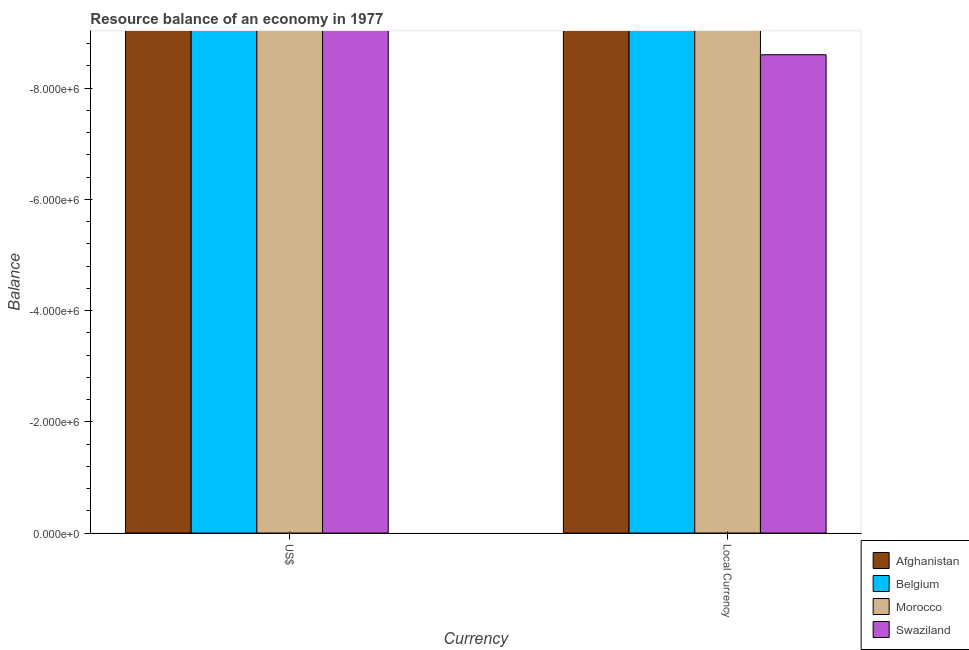How many different coloured bars are there?
Keep it short and to the point. 0. What is the label of the 1st group of bars from the left?
Your answer should be very brief. US$. What is the resource balance in constant us$ in Belgium?
Ensure brevity in your answer.  0. In how many countries, is the resource balance in us$ greater than the average resource balance in us$ taken over all countries?
Give a very brief answer. 0. How many bars are there?
Your answer should be compact. 0. Are all the bars in the graph horizontal?
Keep it short and to the point. No. What is the difference between two consecutive major ticks on the Y-axis?
Offer a terse response. 2.00e+06. Does the graph contain grids?
Keep it short and to the point. No. Where does the legend appear in the graph?
Provide a succinct answer. Bottom right. How are the legend labels stacked?
Ensure brevity in your answer.  Vertical. What is the title of the graph?
Your response must be concise. Resource balance of an economy in 1977. What is the label or title of the X-axis?
Your answer should be compact. Currency. What is the label or title of the Y-axis?
Your answer should be compact. Balance. What is the Balance in Afghanistan in US$?
Provide a short and direct response. 0. What is the Balance in Belgium in US$?
Provide a succinct answer. 0. What is the Balance of Swaziland in US$?
Your answer should be very brief. 0. What is the Balance of Belgium in Local Currency?
Ensure brevity in your answer.  0. What is the Balance of Morocco in Local Currency?
Your response must be concise. 0. What is the total Balance of Afghanistan in the graph?
Give a very brief answer. 0. What is the total Balance of Belgium in the graph?
Offer a very short reply. 0. What is the total Balance of Morocco in the graph?
Offer a terse response. 0. What is the total Balance in Swaziland in the graph?
Provide a short and direct response. 0. What is the average Balance of Belgium per Currency?
Your answer should be very brief. 0. What is the average Balance in Swaziland per Currency?
Offer a very short reply. 0. 